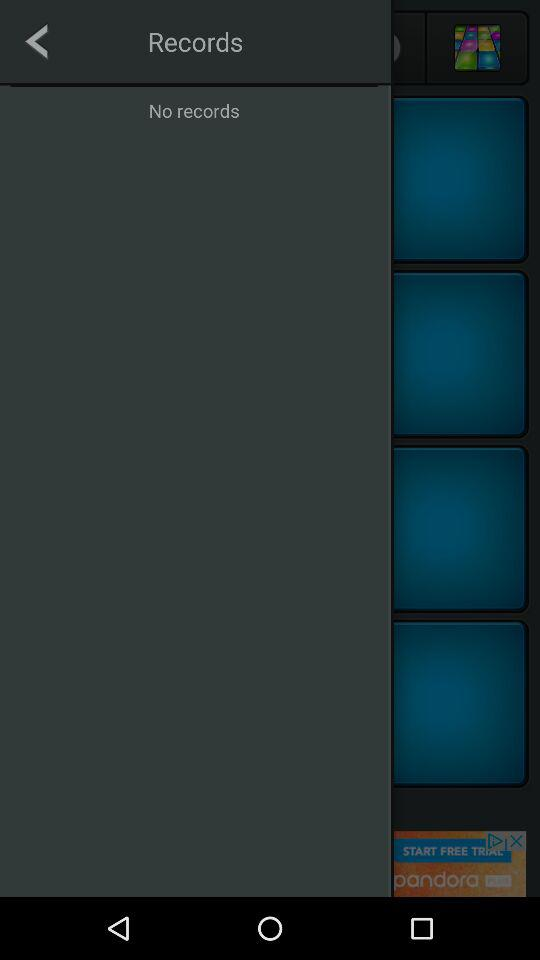How many blue squares with black borders are there?
Answer the question using a single word or phrase. 4 